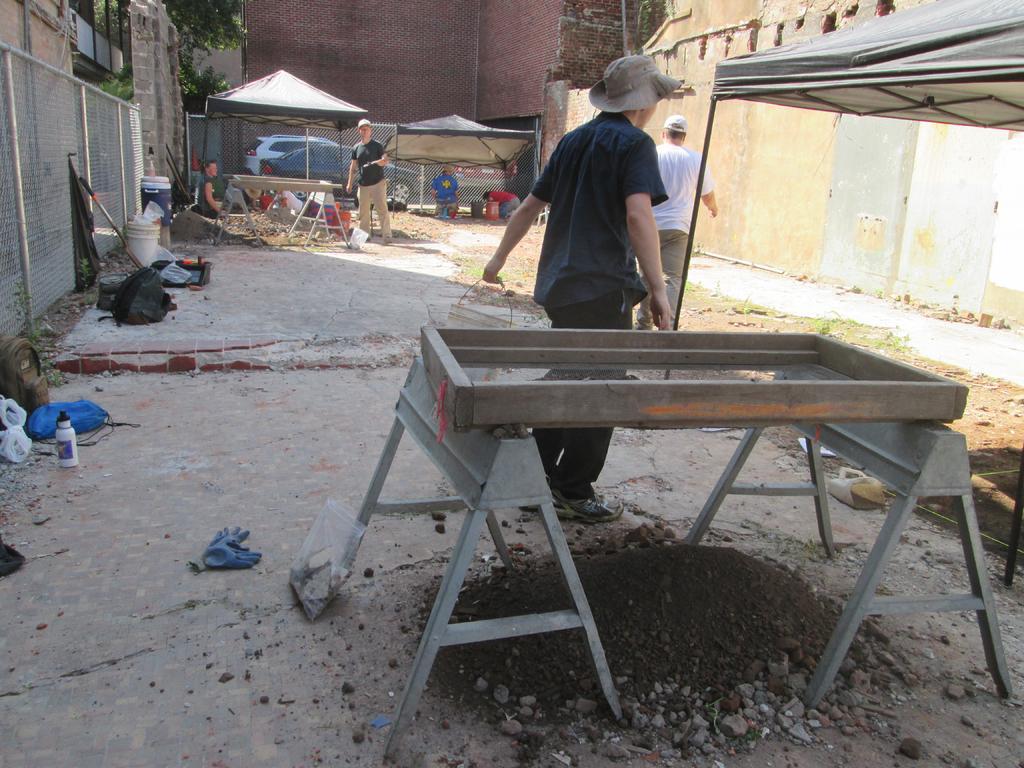Can you describe this image briefly? The person wearing blue shirt is carrying a bucket in his hand and there is some object in front of him and there are few people and buildings in the background. 